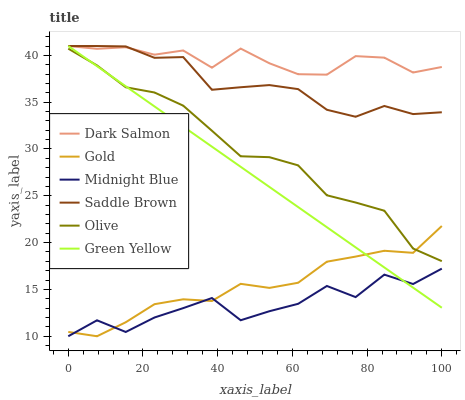Does Midnight Blue have the minimum area under the curve?
Answer yes or no. Yes. Does Dark Salmon have the maximum area under the curve?
Answer yes or no. Yes. Does Gold have the minimum area under the curve?
Answer yes or no. No. Does Gold have the maximum area under the curve?
Answer yes or no. No. Is Green Yellow the smoothest?
Answer yes or no. Yes. Is Midnight Blue the roughest?
Answer yes or no. Yes. Is Gold the smoothest?
Answer yes or no. No. Is Gold the roughest?
Answer yes or no. No. Does Midnight Blue have the lowest value?
Answer yes or no. Yes. Does Dark Salmon have the lowest value?
Answer yes or no. No. Does Saddle Brown have the highest value?
Answer yes or no. Yes. Does Gold have the highest value?
Answer yes or no. No. Is Midnight Blue less than Dark Salmon?
Answer yes or no. Yes. Is Saddle Brown greater than Gold?
Answer yes or no. Yes. Does Dark Salmon intersect Saddle Brown?
Answer yes or no. Yes. Is Dark Salmon less than Saddle Brown?
Answer yes or no. No. Is Dark Salmon greater than Saddle Brown?
Answer yes or no. No. Does Midnight Blue intersect Dark Salmon?
Answer yes or no. No. 